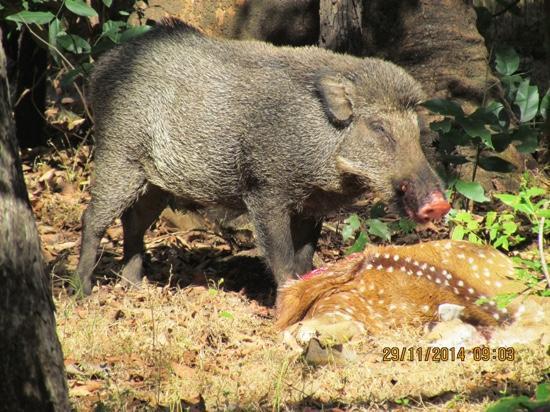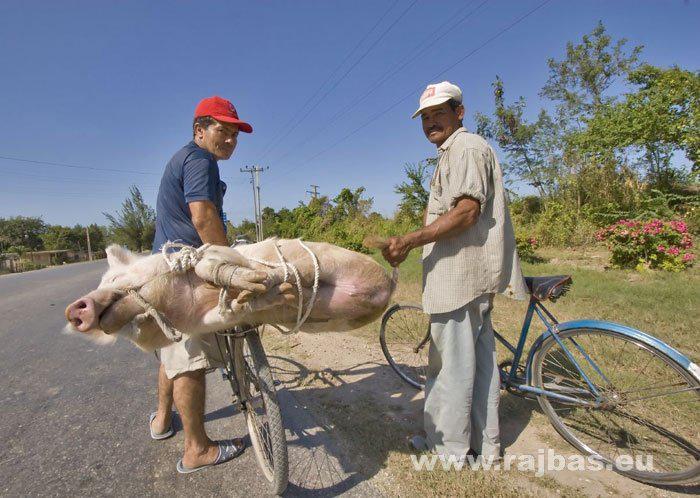The first image is the image on the left, the second image is the image on the right. Assess this claim about the two images: "There is at least one person in one of the photos.". Correct or not? Answer yes or no. Yes. The first image is the image on the left, the second image is the image on the right. For the images displayed, is the sentence "A pig is on its side." factually correct? Answer yes or no. Yes. 